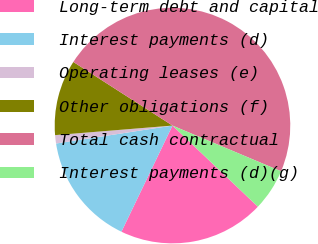Convert chart. <chart><loc_0><loc_0><loc_500><loc_500><pie_chart><fcel>Long-term debt and capital<fcel>Interest payments (d)<fcel>Operating leases (e)<fcel>Other obligations (f)<fcel>Total cash contractual<fcel>Interest payments (d)(g)<nl><fcel>20.04%<fcel>15.43%<fcel>1.14%<fcel>10.37%<fcel>47.26%<fcel>5.75%<nl></chart> 